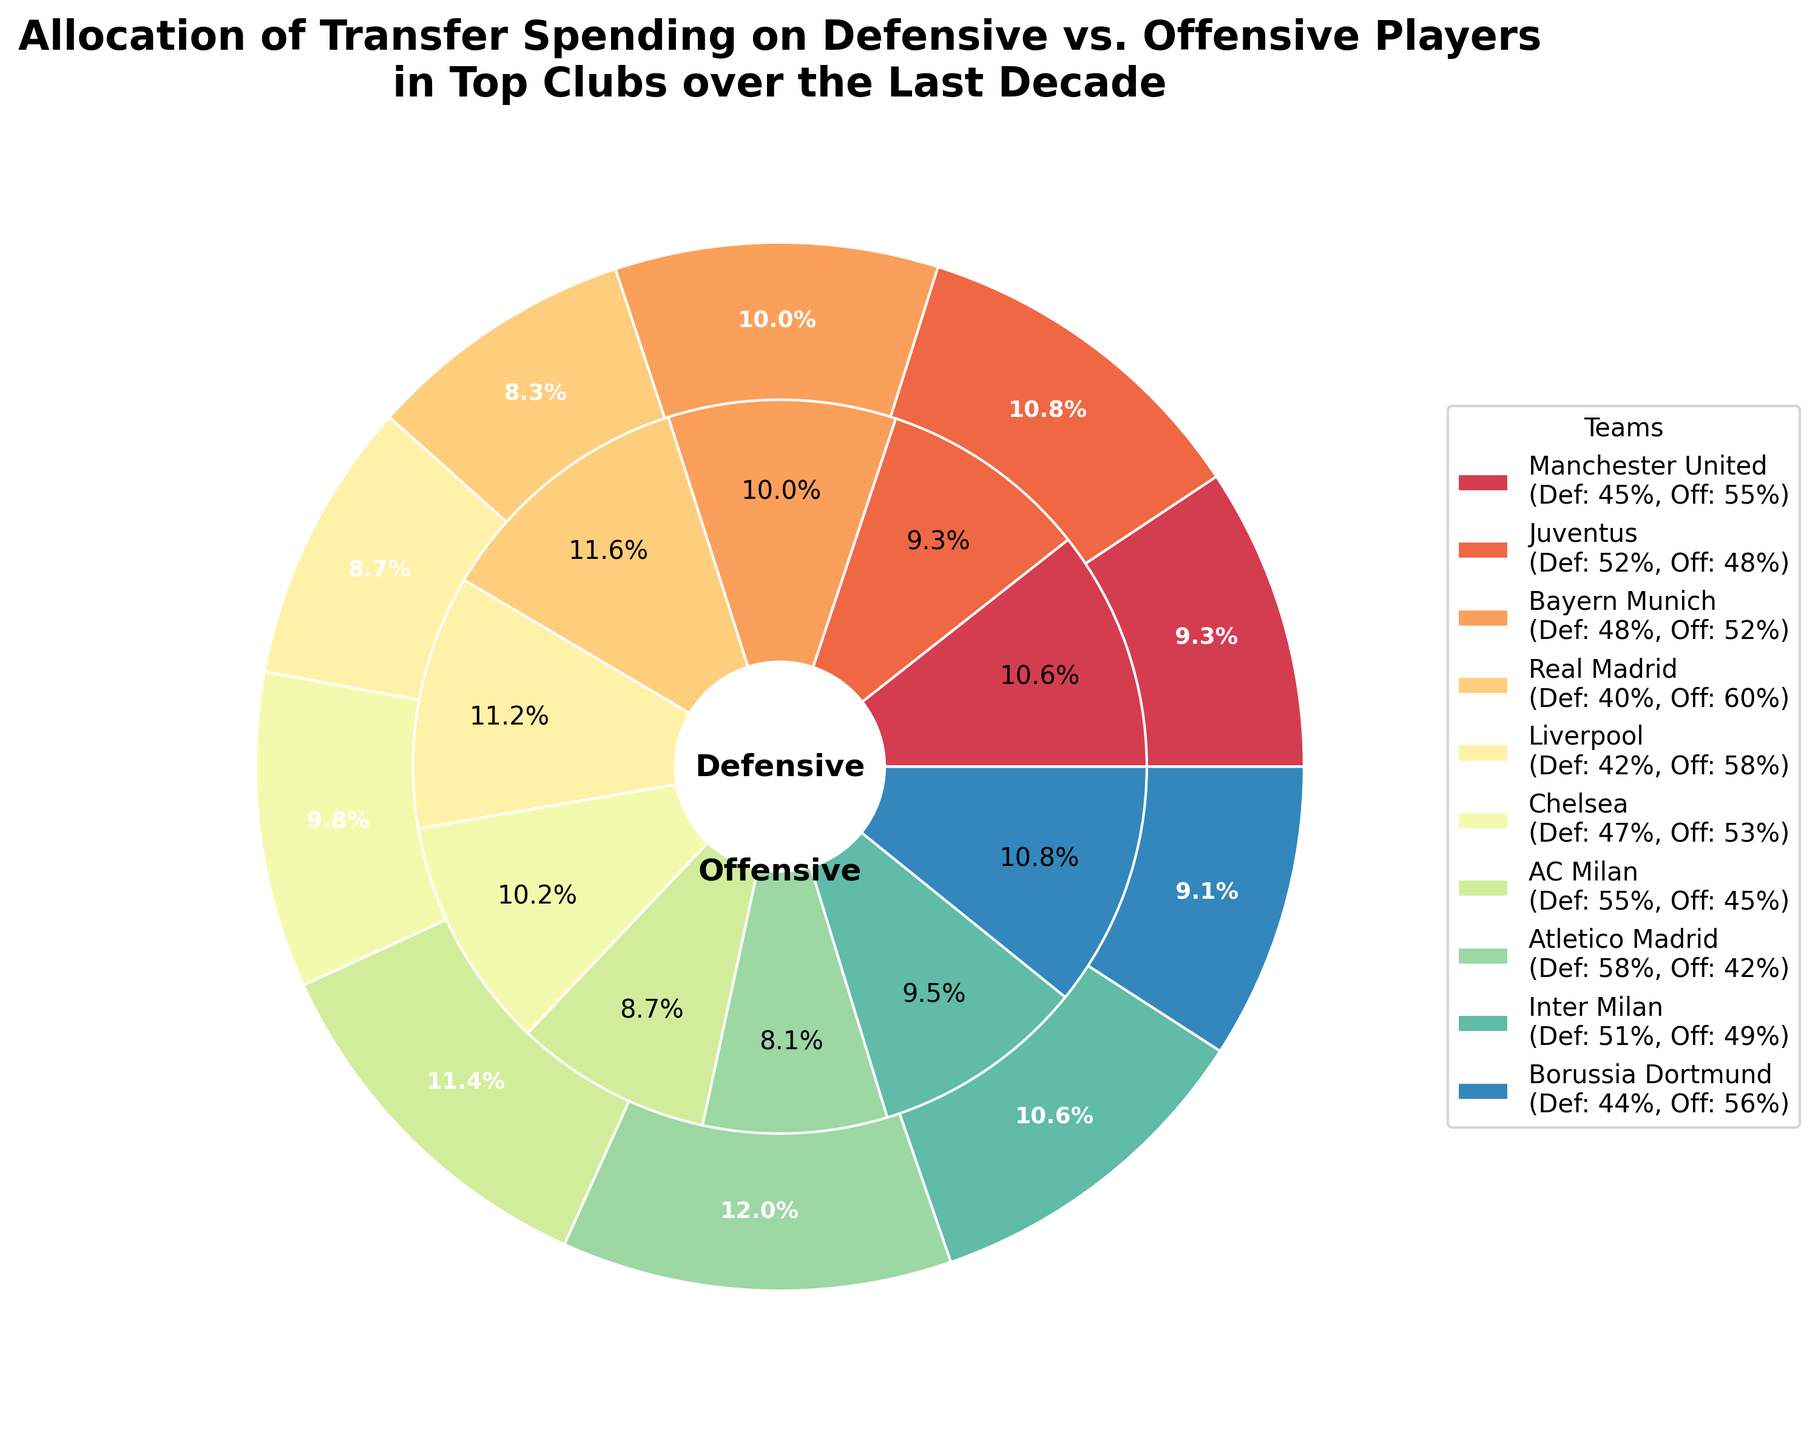Which team has the highest defensive spending percentage? By looking at the percentage values of each team in the defensive spending pie chart, Atletico Madrid has the highest defensive spending percentage at 58%.
Answer: Atletico Madrid How much more does Real Madrid spend on offensive players compared to defensive players? Real Madrid spends 60% on offensive players and 40% on defensive players. The difference is 60% - 40% = 20%.
Answer: 20% What is the average defensive spending percentage across all the teams? Add up all the defensive spending percentages and divide by the number of teams: (45 + 52 + 48 + 40 + 42 + 47 + 55 + 58 + 51 + 44) / 10 = 48.2%.
Answer: 48.2% Which team has the smallest difference between their spending on defensive and offensive players? Calculate the absolute difference between defensive and offensive spending for each team and compare: Manchester United (10%), Juventus (4%), Bayern Munich (4%), Real Madrid (20%), Liverpool (16%), Chelsea (6%), AC Milan (10%), Atletico Madrid (16%), Inter Milan (2%), Borussia Dortmund (12%). The smallest difference is Inter Milan at 2%.
Answer: Inter Milan Which team spends more on defensive players, Chelsea or Borussia Dortmund? By comparing their defensive spending percentages, Chelsea spends 47% while Borussia Dortmund spends 44%, meaning Chelsea spends more on defensive players.
Answer: Chelsea How much total spending percentage is dedicated to defensive players by Manchester United and Liverpool collectively? Sum the defensive spending percentages of Manchester United and Liverpool: 45% + 42% = 87%.
Answer: 87% Which team has a greater focus on offensive spending, Bayern Munich or Real Madrid? Comparing the offensive spending percentages, Bayern Munich has 52% and Real Madrid has 60%. Thus, Real Madrid has a greater focus on offensive spending.
Answer: Real Madrid Calculate the difference between the highest and the lowest defensive spending percentages among the teams. The highest defensive spending percentage is Atletico Madrid at 58%, and the lowest is Real Madrid at 40%. Thus, the difference is 58% - 40% = 18%.
Answer: 18% Identify the team with nearly equal spending (difference within 5%) on defensive and offensive players. By examining the spending percentages and their differences for each team: Manchester United (10%), Juventus (4%), Bayern Munich (4%), Chelsea (6%), AC Milan (10%), Atletico Madrid (16%), Inter Milan (2%), Borussia Dortmund (12%), Juventus, Bayern Munich, and Inter Milan have a difference within 5%.
Answer: Juventus, Bayern Munich, Inter Milan Which teams spend more than 50% on defensive players? Identify teams with defensive spending percentages greater than 50%: Juventus (52%), AC Milan (55%), Atletico Madrid (58%), Inter Milan (51%).
Answer: Juventus, AC Milan, Atletico Madrid, Inter Milan 